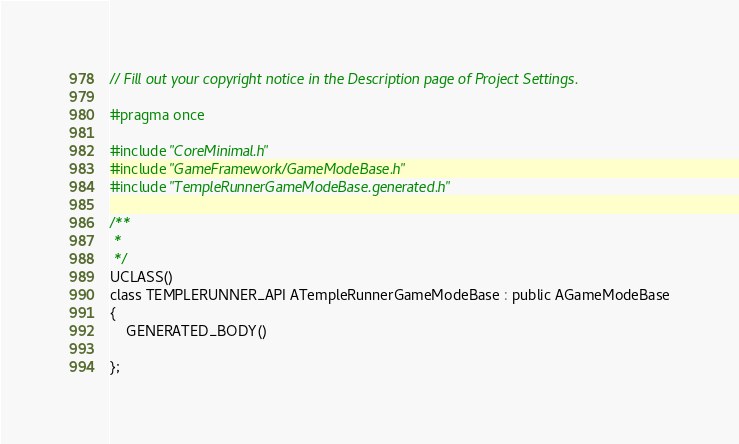<code> <loc_0><loc_0><loc_500><loc_500><_C_>// Fill out your copyright notice in the Description page of Project Settings.

#pragma once

#include "CoreMinimal.h"
#include "GameFramework/GameModeBase.h"
#include "TempleRunnerGameModeBase.generated.h"

/**
 * 
 */
UCLASS()
class TEMPLERUNNER_API ATempleRunnerGameModeBase : public AGameModeBase
{
	GENERATED_BODY()
	
};
</code> 